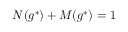<formula> <loc_0><loc_0><loc_500><loc_500>N ( g ^ { * } ) + M ( g ^ { * } ) = 1</formula> 